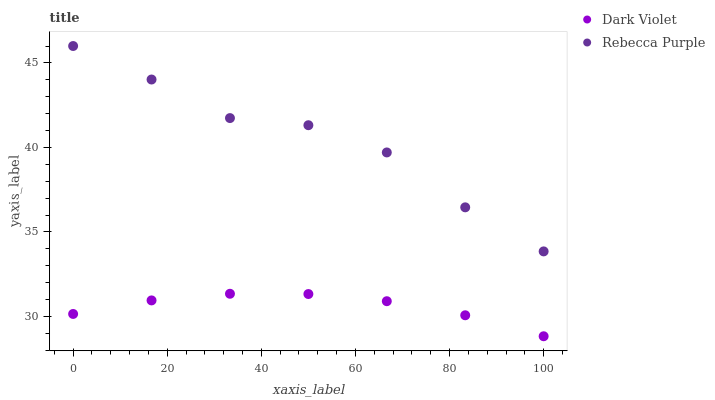Does Dark Violet have the minimum area under the curve?
Answer yes or no. Yes. Does Rebecca Purple have the maximum area under the curve?
Answer yes or no. Yes. Does Dark Violet have the maximum area under the curve?
Answer yes or no. No. Is Dark Violet the smoothest?
Answer yes or no. Yes. Is Rebecca Purple the roughest?
Answer yes or no. Yes. Is Dark Violet the roughest?
Answer yes or no. No. Does Dark Violet have the lowest value?
Answer yes or no. Yes. Does Rebecca Purple have the highest value?
Answer yes or no. Yes. Does Dark Violet have the highest value?
Answer yes or no. No. Is Dark Violet less than Rebecca Purple?
Answer yes or no. Yes. Is Rebecca Purple greater than Dark Violet?
Answer yes or no. Yes. Does Dark Violet intersect Rebecca Purple?
Answer yes or no. No. 